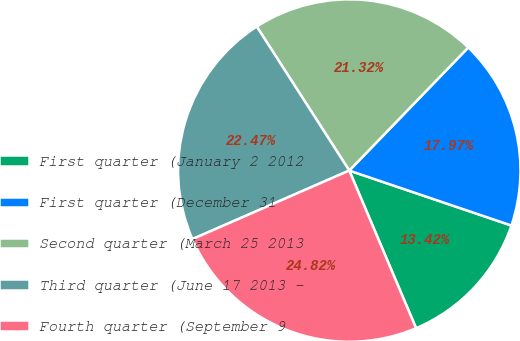<chart> <loc_0><loc_0><loc_500><loc_500><pie_chart><fcel>First quarter (January 2 2012<fcel>First quarter (December 31<fcel>Second quarter (March 25 2013<fcel>Third quarter (June 17 2013 -<fcel>Fourth quarter (September 9<nl><fcel>13.42%<fcel>17.97%<fcel>21.32%<fcel>22.47%<fcel>24.82%<nl></chart> 